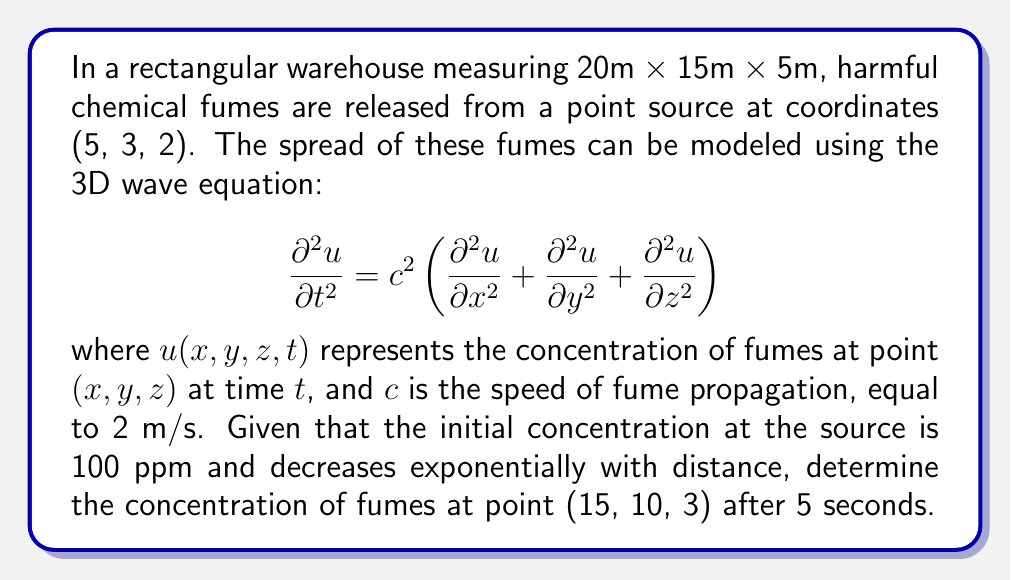Can you answer this question? To solve this problem, we'll use the solution to the 3D wave equation for a point source:

$$u(x,y,z,t) = \frac{A}{r} f(r-ct)$$

where $A$ is the amplitude, $r$ is the distance from the source, and $f$ is a function describing the initial pulse shape.

Step 1: Calculate the distance $r$ from the source (5, 3, 2) to the point of interest (15, 10, 3):
$$r = \sqrt{(15-5)^2 + (10-3)^2 + (3-2)^2} = \sqrt{100 + 49 + 1} = \sqrt{150} \approx 12.25 \text{ m}$$

Step 2: Determine the time it takes for the fumes to reach the point of interest:
$$t_{travel} = \frac{r}{c} = \frac{12.25}{2} = 6.125 \text{ s}$$

Step 3: Since the given time (5 s) is less than the travel time, we need to use an exponential decay function to model the concentration:
$$u(r,t) = A e^{-k(r-ct)}$$
where $k$ is a decay constant.

Step 4: Calculate the decay constant $k$ using the initial condition that the concentration is 100 ppm at the source:
$$100 = A e^{-k(0)} \implies A = 100$$

Step 5: Assume that the concentration decreases to 1% of its initial value at a distance of 10 m:
$$1 = 100 e^{-10k} \implies k = \frac{\ln(100)}{10} \approx 0.4605$$

Step 6: Calculate the concentration at the point of interest after 5 seconds:
$$u(12.25, 5) = 100 e^{-0.4605(12.25 - 2 \cdot 5)} = 100 e^{-1.035} \approx 35.52 \text{ ppm}$$
Answer: 35.52 ppm 